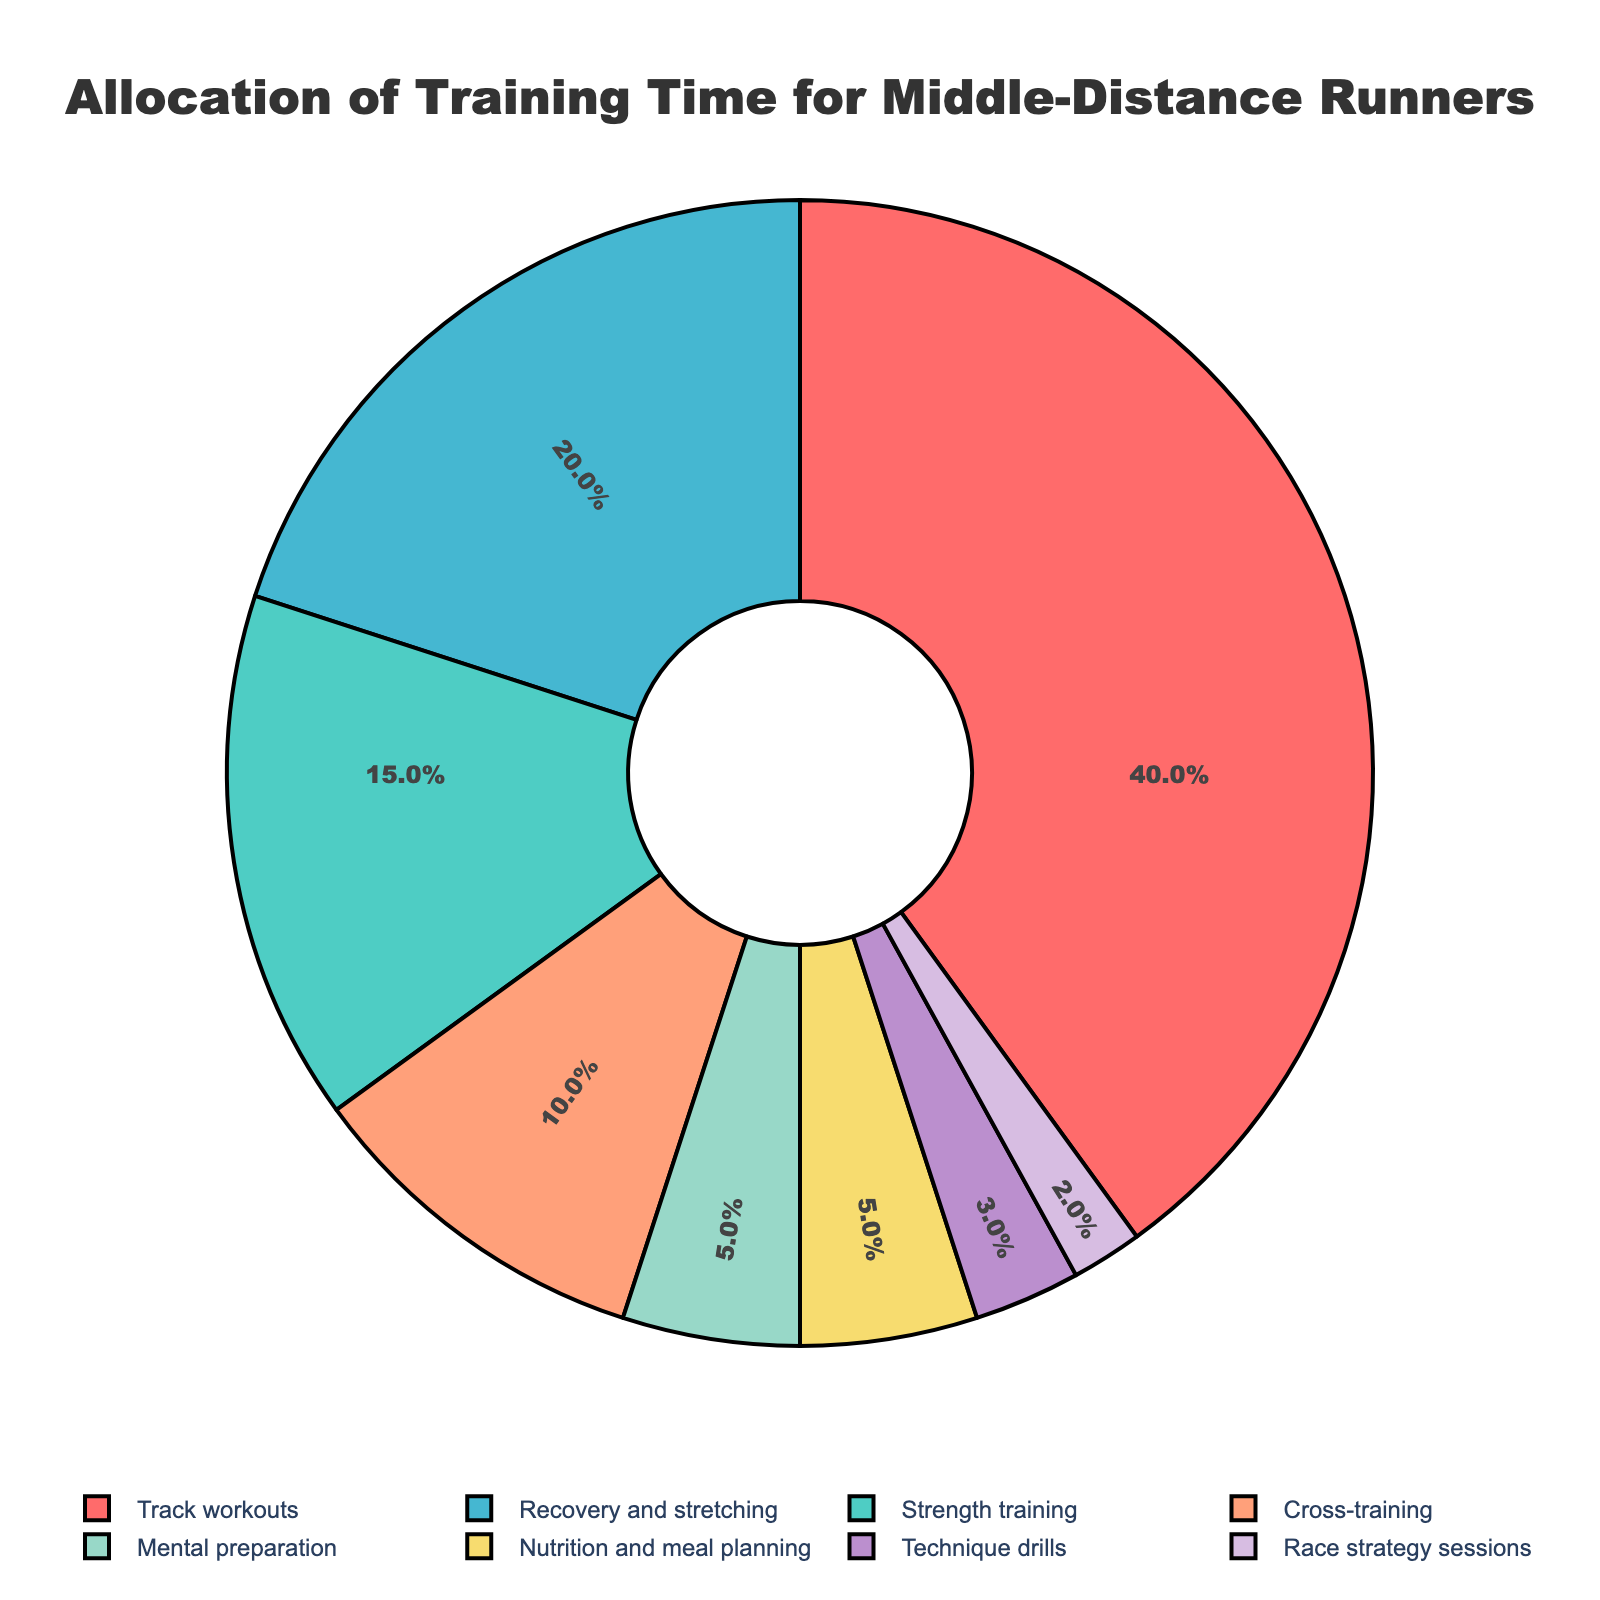What's the percentage of time allocated to Recovery and stretching and Technique drills combined? Recovery and stretching is 20% and Technique drills is 3%. Adding them together results in 20% + 3% = 23%
Answer: 23% Which training activity has the highest allocation of time? By observing the pie chart, Track workouts have the highest allocation at 40%.
Answer: Track workouts How much more percentage of time is allocated to Strength training compared to Mental preparation? The percentage allocated to Strength training is 15% and to Mental preparation is 5%. The difference is 15% - 5% = 10%.
Answer: 10% What is the smallest slice in the pie chart and its percentage? The smallest slice in the chart is Race strategy sessions with an allocation of 2%.
Answer: Race strategy sessions, 2% Rank the training categories from highest to lowest in terms of time allocation. From the chart: 1. Track workouts (40%), 2. Recovery and stretching (20%), 3. Strength training (15%), 4. Cross-training (10%), 5. Mental preparation & Nutrition and meal planning (5% each), 7. Technique drills (3%), 8. Race strategy sessions (2%)
Answer: Track workouts, Recovery and stretching, Strength training, Cross-training, Mental preparation & Nutrition and meal planning, Technique drills, Race strategy sessions What percentage of time is allocated to activities other than Track workouts? The allocation for activities other than Track workouts is 100% - 40% = 60%.
Answer: 60% Is the combined percentage of Nutrition and meal planning, and Technique drills greater than Cross-training? Nutrition and meal planning is 5% and Technique drills is 3%. Their combined percentage is 5% + 3% = 8%, which is less than Cross-training at 10%.
Answer: No Which activity contributes a 5% time allocation, and how many such slices are there? By observing, both Mental preparation and Nutrition and meal planning have a 5% allocation each.
Answer: Mental preparation and Nutrition and meal planning; 2 slices 